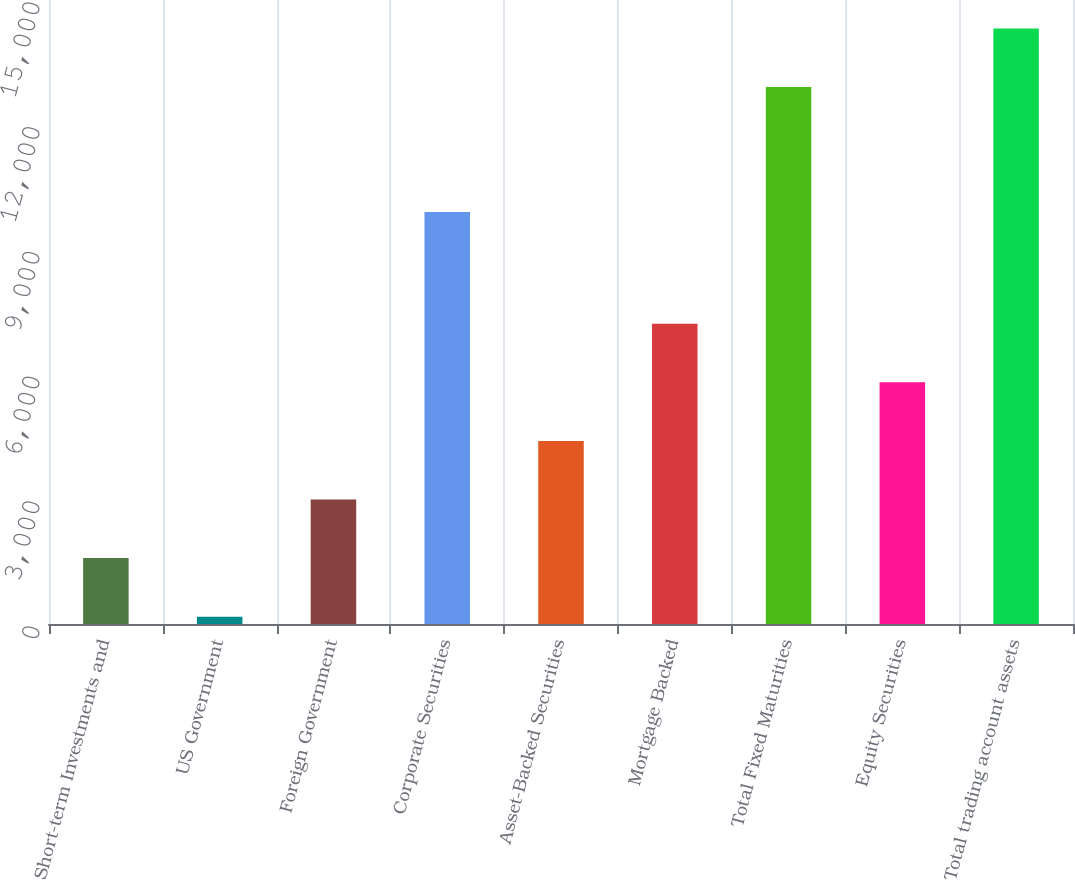<chart> <loc_0><loc_0><loc_500><loc_500><bar_chart><fcel>Short-term Investments and<fcel>US Government<fcel>Foreign Government<fcel>Corporate Securities<fcel>Asset-Backed Securities<fcel>Mortgage Backed<fcel>Total Fixed Maturities<fcel>Equity Securities<fcel>Total trading account assets<nl><fcel>1583.7<fcel>175<fcel>2992.4<fcel>9904<fcel>4401.1<fcel>7218.5<fcel>12906<fcel>5809.8<fcel>14314.7<nl></chart> 